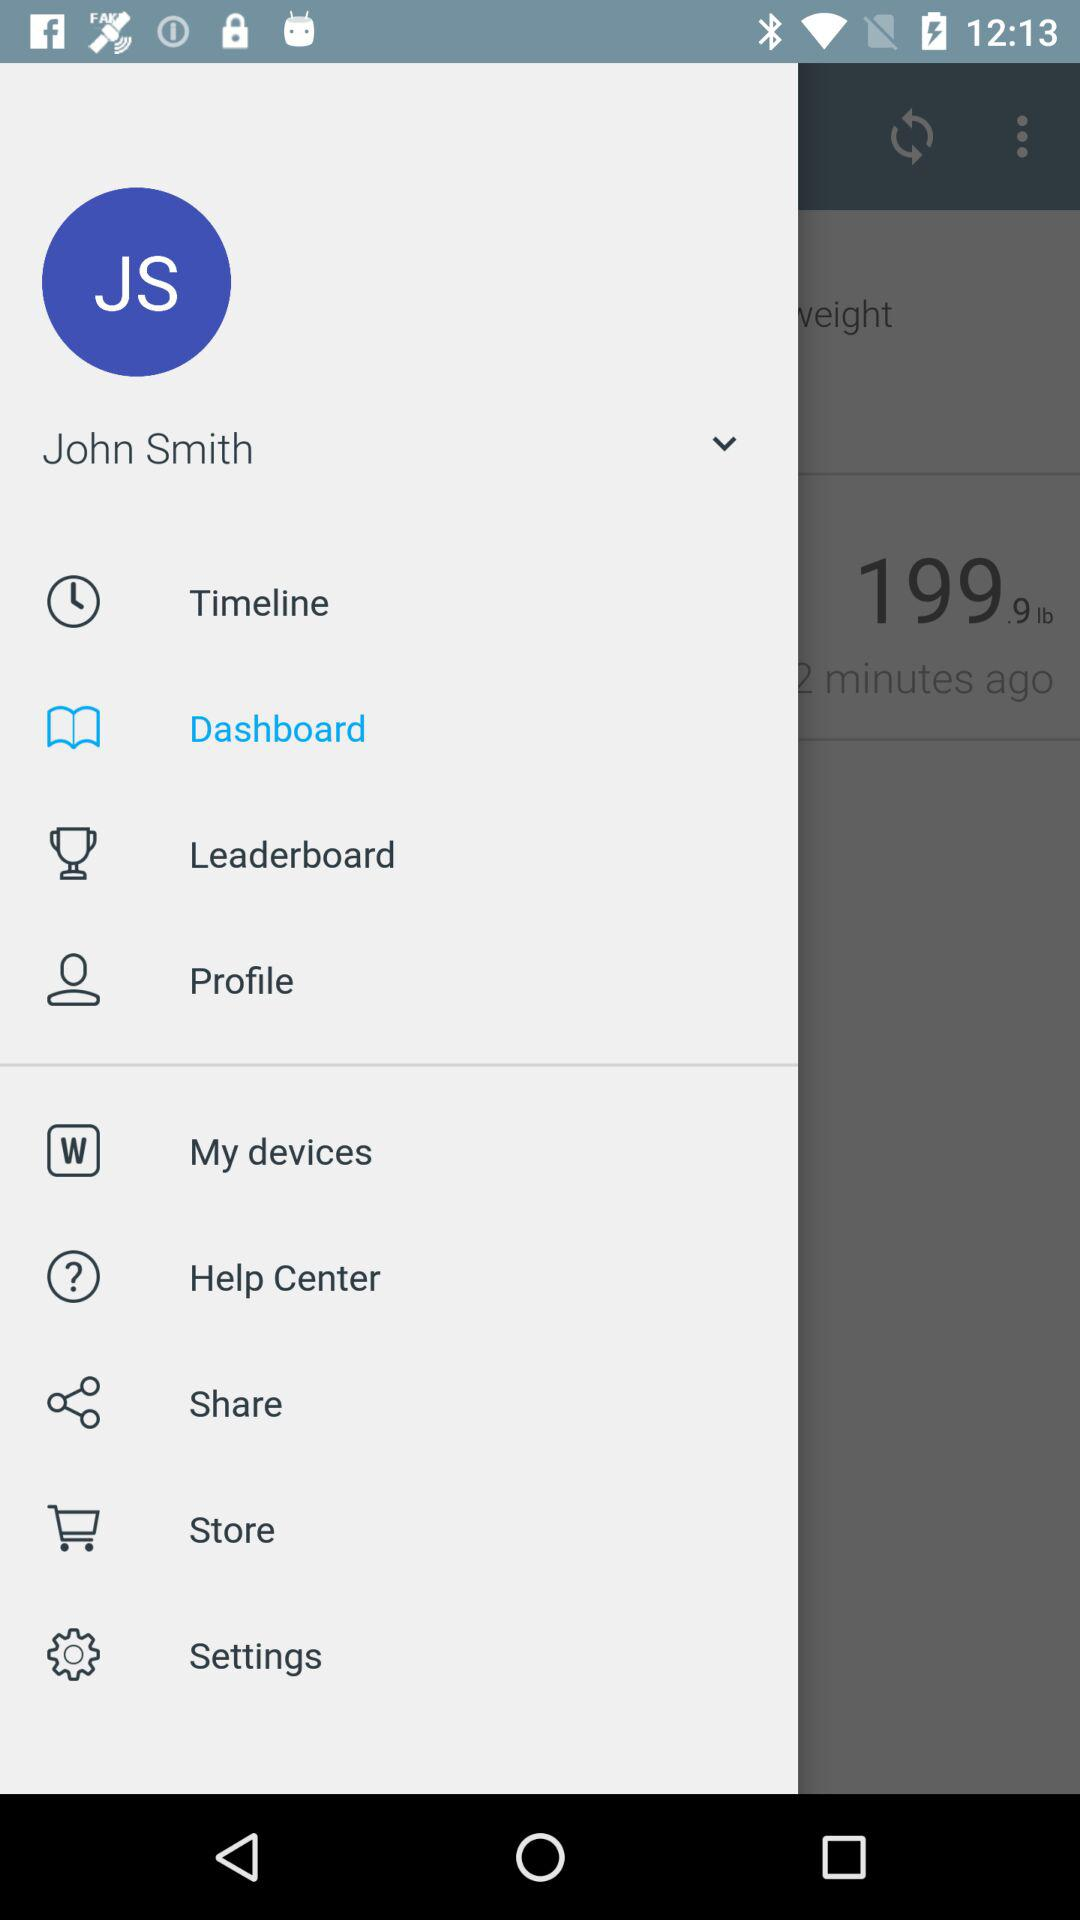What is the user name? The user name is John Smith. 